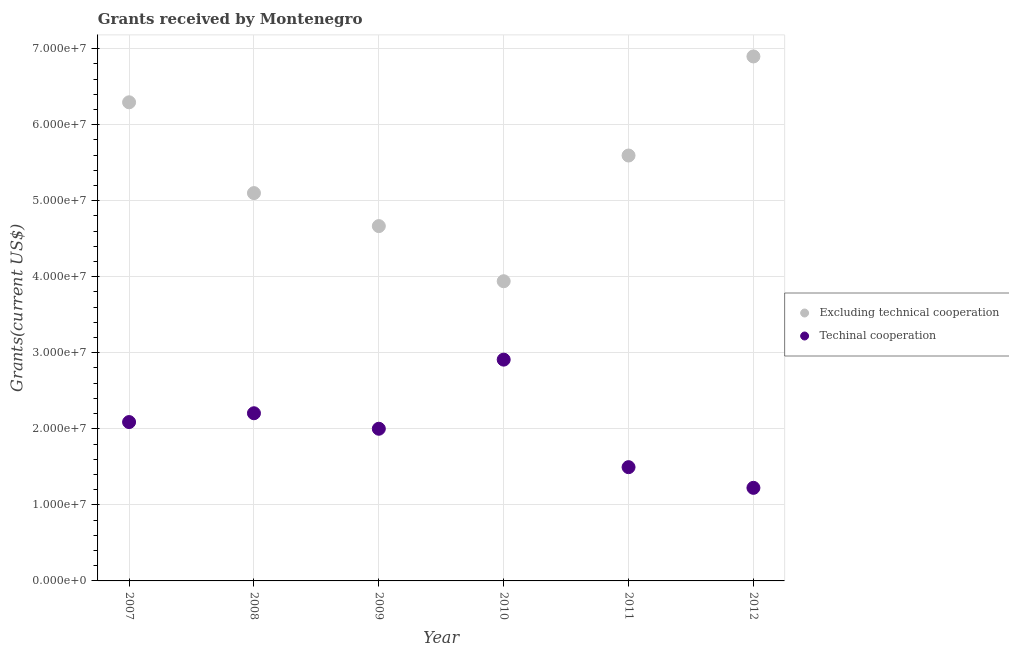What is the amount of grants received(excluding technical cooperation) in 2010?
Provide a succinct answer. 3.94e+07. Across all years, what is the maximum amount of grants received(including technical cooperation)?
Your answer should be compact. 2.91e+07. Across all years, what is the minimum amount of grants received(excluding technical cooperation)?
Your answer should be very brief. 3.94e+07. What is the total amount of grants received(excluding technical cooperation) in the graph?
Provide a short and direct response. 3.25e+08. What is the difference between the amount of grants received(excluding technical cooperation) in 2007 and that in 2009?
Give a very brief answer. 1.63e+07. What is the difference between the amount of grants received(excluding technical cooperation) in 2007 and the amount of grants received(including technical cooperation) in 2009?
Give a very brief answer. 4.29e+07. What is the average amount of grants received(including technical cooperation) per year?
Ensure brevity in your answer.  1.99e+07. In the year 2010, what is the difference between the amount of grants received(excluding technical cooperation) and amount of grants received(including technical cooperation)?
Provide a succinct answer. 1.03e+07. In how many years, is the amount of grants received(excluding technical cooperation) greater than 26000000 US$?
Ensure brevity in your answer.  6. What is the ratio of the amount of grants received(excluding technical cooperation) in 2009 to that in 2011?
Offer a terse response. 0.83. Is the amount of grants received(excluding technical cooperation) in 2010 less than that in 2012?
Keep it short and to the point. Yes. What is the difference between the highest and the second highest amount of grants received(including technical cooperation)?
Your answer should be very brief. 7.05e+06. What is the difference between the highest and the lowest amount of grants received(including technical cooperation)?
Offer a very short reply. 1.69e+07. In how many years, is the amount of grants received(excluding technical cooperation) greater than the average amount of grants received(excluding technical cooperation) taken over all years?
Make the answer very short. 3. Is the sum of the amount of grants received(including technical cooperation) in 2008 and 2012 greater than the maximum amount of grants received(excluding technical cooperation) across all years?
Your response must be concise. No. Does the amount of grants received(including technical cooperation) monotonically increase over the years?
Offer a very short reply. No. How many dotlines are there?
Give a very brief answer. 2. What is the difference between two consecutive major ticks on the Y-axis?
Ensure brevity in your answer.  1.00e+07. Does the graph contain any zero values?
Offer a terse response. No. Where does the legend appear in the graph?
Offer a very short reply. Center right. What is the title of the graph?
Offer a terse response. Grants received by Montenegro. Does "Number of arrivals" appear as one of the legend labels in the graph?
Your response must be concise. No. What is the label or title of the X-axis?
Provide a succinct answer. Year. What is the label or title of the Y-axis?
Provide a succinct answer. Grants(current US$). What is the Grants(current US$) in Excluding technical cooperation in 2007?
Give a very brief answer. 6.29e+07. What is the Grants(current US$) of Techinal cooperation in 2007?
Your answer should be very brief. 2.09e+07. What is the Grants(current US$) of Excluding technical cooperation in 2008?
Your response must be concise. 5.10e+07. What is the Grants(current US$) in Techinal cooperation in 2008?
Keep it short and to the point. 2.20e+07. What is the Grants(current US$) in Excluding technical cooperation in 2009?
Provide a succinct answer. 4.67e+07. What is the Grants(current US$) of Techinal cooperation in 2009?
Give a very brief answer. 2.00e+07. What is the Grants(current US$) of Excluding technical cooperation in 2010?
Offer a very short reply. 3.94e+07. What is the Grants(current US$) of Techinal cooperation in 2010?
Your answer should be very brief. 2.91e+07. What is the Grants(current US$) of Excluding technical cooperation in 2011?
Offer a very short reply. 5.59e+07. What is the Grants(current US$) in Techinal cooperation in 2011?
Offer a very short reply. 1.50e+07. What is the Grants(current US$) of Excluding technical cooperation in 2012?
Ensure brevity in your answer.  6.90e+07. What is the Grants(current US$) of Techinal cooperation in 2012?
Offer a very short reply. 1.22e+07. Across all years, what is the maximum Grants(current US$) in Excluding technical cooperation?
Keep it short and to the point. 6.90e+07. Across all years, what is the maximum Grants(current US$) in Techinal cooperation?
Your response must be concise. 2.91e+07. Across all years, what is the minimum Grants(current US$) in Excluding technical cooperation?
Make the answer very short. 3.94e+07. Across all years, what is the minimum Grants(current US$) in Techinal cooperation?
Offer a terse response. 1.22e+07. What is the total Grants(current US$) in Excluding technical cooperation in the graph?
Your answer should be very brief. 3.25e+08. What is the total Grants(current US$) in Techinal cooperation in the graph?
Your answer should be compact. 1.19e+08. What is the difference between the Grants(current US$) of Excluding technical cooperation in 2007 and that in 2008?
Your answer should be compact. 1.19e+07. What is the difference between the Grants(current US$) in Techinal cooperation in 2007 and that in 2008?
Your answer should be compact. -1.16e+06. What is the difference between the Grants(current US$) in Excluding technical cooperation in 2007 and that in 2009?
Offer a very short reply. 1.63e+07. What is the difference between the Grants(current US$) in Techinal cooperation in 2007 and that in 2009?
Provide a succinct answer. 8.80e+05. What is the difference between the Grants(current US$) of Excluding technical cooperation in 2007 and that in 2010?
Keep it short and to the point. 2.35e+07. What is the difference between the Grants(current US$) of Techinal cooperation in 2007 and that in 2010?
Give a very brief answer. -8.21e+06. What is the difference between the Grants(current US$) in Excluding technical cooperation in 2007 and that in 2011?
Your response must be concise. 7.00e+06. What is the difference between the Grants(current US$) of Techinal cooperation in 2007 and that in 2011?
Provide a succinct answer. 5.93e+06. What is the difference between the Grants(current US$) in Excluding technical cooperation in 2007 and that in 2012?
Keep it short and to the point. -6.03e+06. What is the difference between the Grants(current US$) of Techinal cooperation in 2007 and that in 2012?
Make the answer very short. 8.65e+06. What is the difference between the Grants(current US$) of Excluding technical cooperation in 2008 and that in 2009?
Keep it short and to the point. 4.34e+06. What is the difference between the Grants(current US$) in Techinal cooperation in 2008 and that in 2009?
Provide a short and direct response. 2.04e+06. What is the difference between the Grants(current US$) in Excluding technical cooperation in 2008 and that in 2010?
Your answer should be compact. 1.16e+07. What is the difference between the Grants(current US$) in Techinal cooperation in 2008 and that in 2010?
Offer a terse response. -7.05e+06. What is the difference between the Grants(current US$) of Excluding technical cooperation in 2008 and that in 2011?
Provide a short and direct response. -4.94e+06. What is the difference between the Grants(current US$) of Techinal cooperation in 2008 and that in 2011?
Give a very brief answer. 7.09e+06. What is the difference between the Grants(current US$) in Excluding technical cooperation in 2008 and that in 2012?
Your answer should be very brief. -1.80e+07. What is the difference between the Grants(current US$) of Techinal cooperation in 2008 and that in 2012?
Provide a succinct answer. 9.81e+06. What is the difference between the Grants(current US$) in Excluding technical cooperation in 2009 and that in 2010?
Provide a short and direct response. 7.25e+06. What is the difference between the Grants(current US$) in Techinal cooperation in 2009 and that in 2010?
Offer a very short reply. -9.09e+06. What is the difference between the Grants(current US$) of Excluding technical cooperation in 2009 and that in 2011?
Ensure brevity in your answer.  -9.28e+06. What is the difference between the Grants(current US$) in Techinal cooperation in 2009 and that in 2011?
Ensure brevity in your answer.  5.05e+06. What is the difference between the Grants(current US$) of Excluding technical cooperation in 2009 and that in 2012?
Provide a short and direct response. -2.23e+07. What is the difference between the Grants(current US$) of Techinal cooperation in 2009 and that in 2012?
Your response must be concise. 7.77e+06. What is the difference between the Grants(current US$) of Excluding technical cooperation in 2010 and that in 2011?
Provide a short and direct response. -1.65e+07. What is the difference between the Grants(current US$) of Techinal cooperation in 2010 and that in 2011?
Provide a short and direct response. 1.41e+07. What is the difference between the Grants(current US$) of Excluding technical cooperation in 2010 and that in 2012?
Your answer should be very brief. -2.96e+07. What is the difference between the Grants(current US$) in Techinal cooperation in 2010 and that in 2012?
Your answer should be very brief. 1.69e+07. What is the difference between the Grants(current US$) of Excluding technical cooperation in 2011 and that in 2012?
Your answer should be very brief. -1.30e+07. What is the difference between the Grants(current US$) of Techinal cooperation in 2011 and that in 2012?
Offer a very short reply. 2.72e+06. What is the difference between the Grants(current US$) in Excluding technical cooperation in 2007 and the Grants(current US$) in Techinal cooperation in 2008?
Give a very brief answer. 4.09e+07. What is the difference between the Grants(current US$) in Excluding technical cooperation in 2007 and the Grants(current US$) in Techinal cooperation in 2009?
Your response must be concise. 4.29e+07. What is the difference between the Grants(current US$) in Excluding technical cooperation in 2007 and the Grants(current US$) in Techinal cooperation in 2010?
Provide a succinct answer. 3.38e+07. What is the difference between the Grants(current US$) of Excluding technical cooperation in 2007 and the Grants(current US$) of Techinal cooperation in 2011?
Offer a very short reply. 4.80e+07. What is the difference between the Grants(current US$) in Excluding technical cooperation in 2007 and the Grants(current US$) in Techinal cooperation in 2012?
Ensure brevity in your answer.  5.07e+07. What is the difference between the Grants(current US$) in Excluding technical cooperation in 2008 and the Grants(current US$) in Techinal cooperation in 2009?
Offer a terse response. 3.10e+07. What is the difference between the Grants(current US$) in Excluding technical cooperation in 2008 and the Grants(current US$) in Techinal cooperation in 2010?
Make the answer very short. 2.19e+07. What is the difference between the Grants(current US$) of Excluding technical cooperation in 2008 and the Grants(current US$) of Techinal cooperation in 2011?
Give a very brief answer. 3.60e+07. What is the difference between the Grants(current US$) in Excluding technical cooperation in 2008 and the Grants(current US$) in Techinal cooperation in 2012?
Provide a succinct answer. 3.88e+07. What is the difference between the Grants(current US$) of Excluding technical cooperation in 2009 and the Grants(current US$) of Techinal cooperation in 2010?
Give a very brief answer. 1.76e+07. What is the difference between the Grants(current US$) of Excluding technical cooperation in 2009 and the Grants(current US$) of Techinal cooperation in 2011?
Ensure brevity in your answer.  3.17e+07. What is the difference between the Grants(current US$) in Excluding technical cooperation in 2009 and the Grants(current US$) in Techinal cooperation in 2012?
Provide a succinct answer. 3.44e+07. What is the difference between the Grants(current US$) in Excluding technical cooperation in 2010 and the Grants(current US$) in Techinal cooperation in 2011?
Keep it short and to the point. 2.44e+07. What is the difference between the Grants(current US$) in Excluding technical cooperation in 2010 and the Grants(current US$) in Techinal cooperation in 2012?
Your answer should be very brief. 2.72e+07. What is the difference between the Grants(current US$) in Excluding technical cooperation in 2011 and the Grants(current US$) in Techinal cooperation in 2012?
Ensure brevity in your answer.  4.37e+07. What is the average Grants(current US$) of Excluding technical cooperation per year?
Keep it short and to the point. 5.42e+07. What is the average Grants(current US$) of Techinal cooperation per year?
Offer a very short reply. 1.99e+07. In the year 2007, what is the difference between the Grants(current US$) in Excluding technical cooperation and Grants(current US$) in Techinal cooperation?
Provide a succinct answer. 4.20e+07. In the year 2008, what is the difference between the Grants(current US$) in Excluding technical cooperation and Grants(current US$) in Techinal cooperation?
Your answer should be very brief. 2.90e+07. In the year 2009, what is the difference between the Grants(current US$) in Excluding technical cooperation and Grants(current US$) in Techinal cooperation?
Your answer should be very brief. 2.66e+07. In the year 2010, what is the difference between the Grants(current US$) in Excluding technical cooperation and Grants(current US$) in Techinal cooperation?
Make the answer very short. 1.03e+07. In the year 2011, what is the difference between the Grants(current US$) of Excluding technical cooperation and Grants(current US$) of Techinal cooperation?
Keep it short and to the point. 4.10e+07. In the year 2012, what is the difference between the Grants(current US$) in Excluding technical cooperation and Grants(current US$) in Techinal cooperation?
Provide a short and direct response. 5.67e+07. What is the ratio of the Grants(current US$) of Excluding technical cooperation in 2007 to that in 2008?
Provide a succinct answer. 1.23. What is the ratio of the Grants(current US$) in Excluding technical cooperation in 2007 to that in 2009?
Give a very brief answer. 1.35. What is the ratio of the Grants(current US$) of Techinal cooperation in 2007 to that in 2009?
Make the answer very short. 1.04. What is the ratio of the Grants(current US$) in Excluding technical cooperation in 2007 to that in 2010?
Make the answer very short. 1.6. What is the ratio of the Grants(current US$) in Techinal cooperation in 2007 to that in 2010?
Provide a short and direct response. 0.72. What is the ratio of the Grants(current US$) in Excluding technical cooperation in 2007 to that in 2011?
Provide a succinct answer. 1.13. What is the ratio of the Grants(current US$) of Techinal cooperation in 2007 to that in 2011?
Give a very brief answer. 1.4. What is the ratio of the Grants(current US$) in Excluding technical cooperation in 2007 to that in 2012?
Offer a very short reply. 0.91. What is the ratio of the Grants(current US$) of Techinal cooperation in 2007 to that in 2012?
Give a very brief answer. 1.71. What is the ratio of the Grants(current US$) in Excluding technical cooperation in 2008 to that in 2009?
Keep it short and to the point. 1.09. What is the ratio of the Grants(current US$) of Techinal cooperation in 2008 to that in 2009?
Offer a very short reply. 1.1. What is the ratio of the Grants(current US$) in Excluding technical cooperation in 2008 to that in 2010?
Your answer should be very brief. 1.29. What is the ratio of the Grants(current US$) in Techinal cooperation in 2008 to that in 2010?
Offer a terse response. 0.76. What is the ratio of the Grants(current US$) of Excluding technical cooperation in 2008 to that in 2011?
Make the answer very short. 0.91. What is the ratio of the Grants(current US$) of Techinal cooperation in 2008 to that in 2011?
Make the answer very short. 1.47. What is the ratio of the Grants(current US$) in Excluding technical cooperation in 2008 to that in 2012?
Provide a short and direct response. 0.74. What is the ratio of the Grants(current US$) in Techinal cooperation in 2008 to that in 2012?
Your response must be concise. 1.8. What is the ratio of the Grants(current US$) in Excluding technical cooperation in 2009 to that in 2010?
Offer a very short reply. 1.18. What is the ratio of the Grants(current US$) of Techinal cooperation in 2009 to that in 2010?
Your answer should be compact. 0.69. What is the ratio of the Grants(current US$) in Excluding technical cooperation in 2009 to that in 2011?
Ensure brevity in your answer.  0.83. What is the ratio of the Grants(current US$) of Techinal cooperation in 2009 to that in 2011?
Make the answer very short. 1.34. What is the ratio of the Grants(current US$) of Excluding technical cooperation in 2009 to that in 2012?
Your response must be concise. 0.68. What is the ratio of the Grants(current US$) of Techinal cooperation in 2009 to that in 2012?
Your answer should be very brief. 1.63. What is the ratio of the Grants(current US$) of Excluding technical cooperation in 2010 to that in 2011?
Ensure brevity in your answer.  0.7. What is the ratio of the Grants(current US$) in Techinal cooperation in 2010 to that in 2011?
Make the answer very short. 1.95. What is the ratio of the Grants(current US$) of Techinal cooperation in 2010 to that in 2012?
Make the answer very short. 2.38. What is the ratio of the Grants(current US$) of Excluding technical cooperation in 2011 to that in 2012?
Ensure brevity in your answer.  0.81. What is the ratio of the Grants(current US$) of Techinal cooperation in 2011 to that in 2012?
Offer a terse response. 1.22. What is the difference between the highest and the second highest Grants(current US$) in Excluding technical cooperation?
Make the answer very short. 6.03e+06. What is the difference between the highest and the second highest Grants(current US$) of Techinal cooperation?
Make the answer very short. 7.05e+06. What is the difference between the highest and the lowest Grants(current US$) of Excluding technical cooperation?
Provide a succinct answer. 2.96e+07. What is the difference between the highest and the lowest Grants(current US$) of Techinal cooperation?
Ensure brevity in your answer.  1.69e+07. 